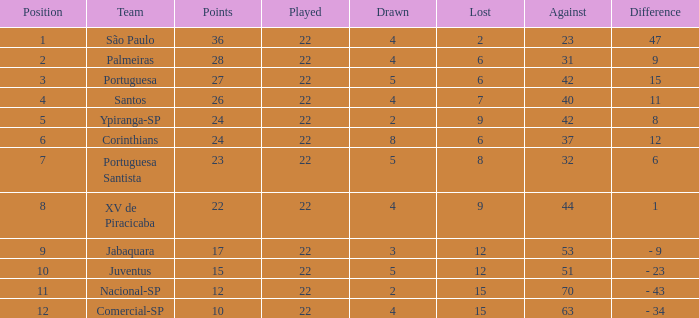Which Against has a Drawn smaller than 5, and a Lost smaller than 6, and a Points larger than 36? 0.0. 